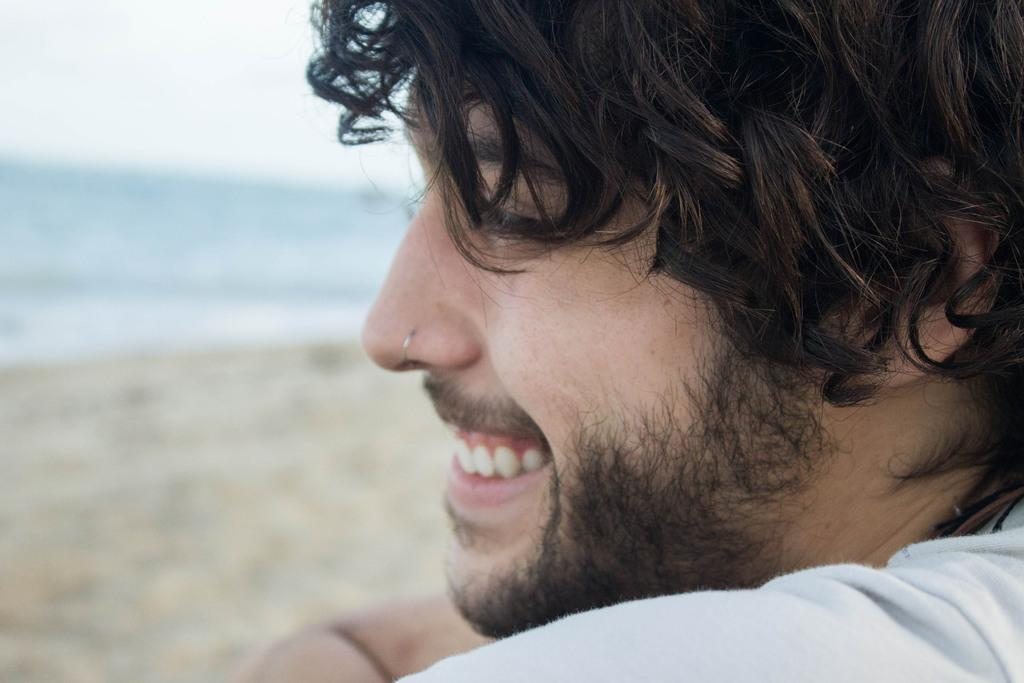What is the main subject of the image? There is a person in the image. Where is the person located? The person is sitting at the seashore. What is the person's facial expression? The person is smiling. How many pizzas are being served in the image? There are no pizzas present in the image. Is the person in the image attending a prison show? There is no reference to a prison or a show in the image, so it is not possible to determine if the person is attending such an event. 